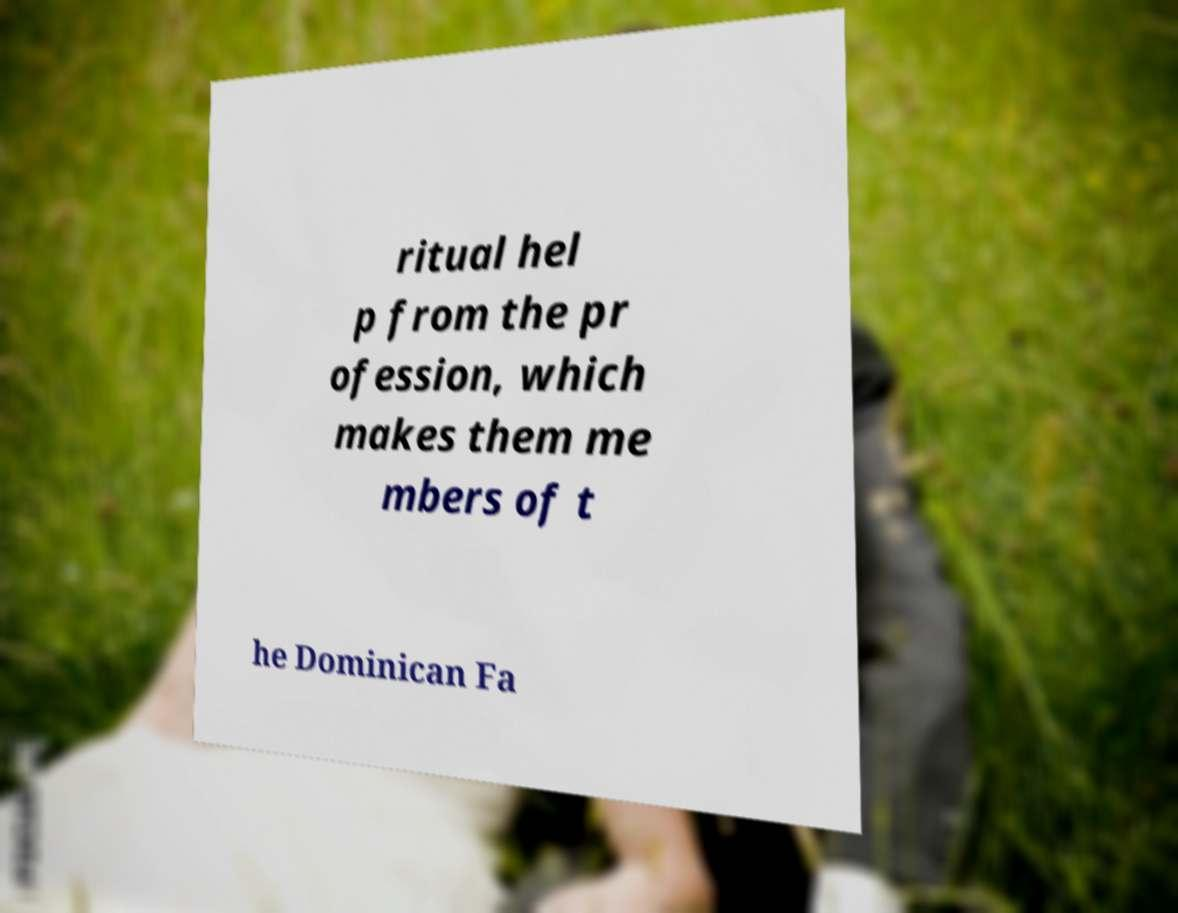There's text embedded in this image that I need extracted. Can you transcribe it verbatim? ritual hel p from the pr ofession, which makes them me mbers of t he Dominican Fa 